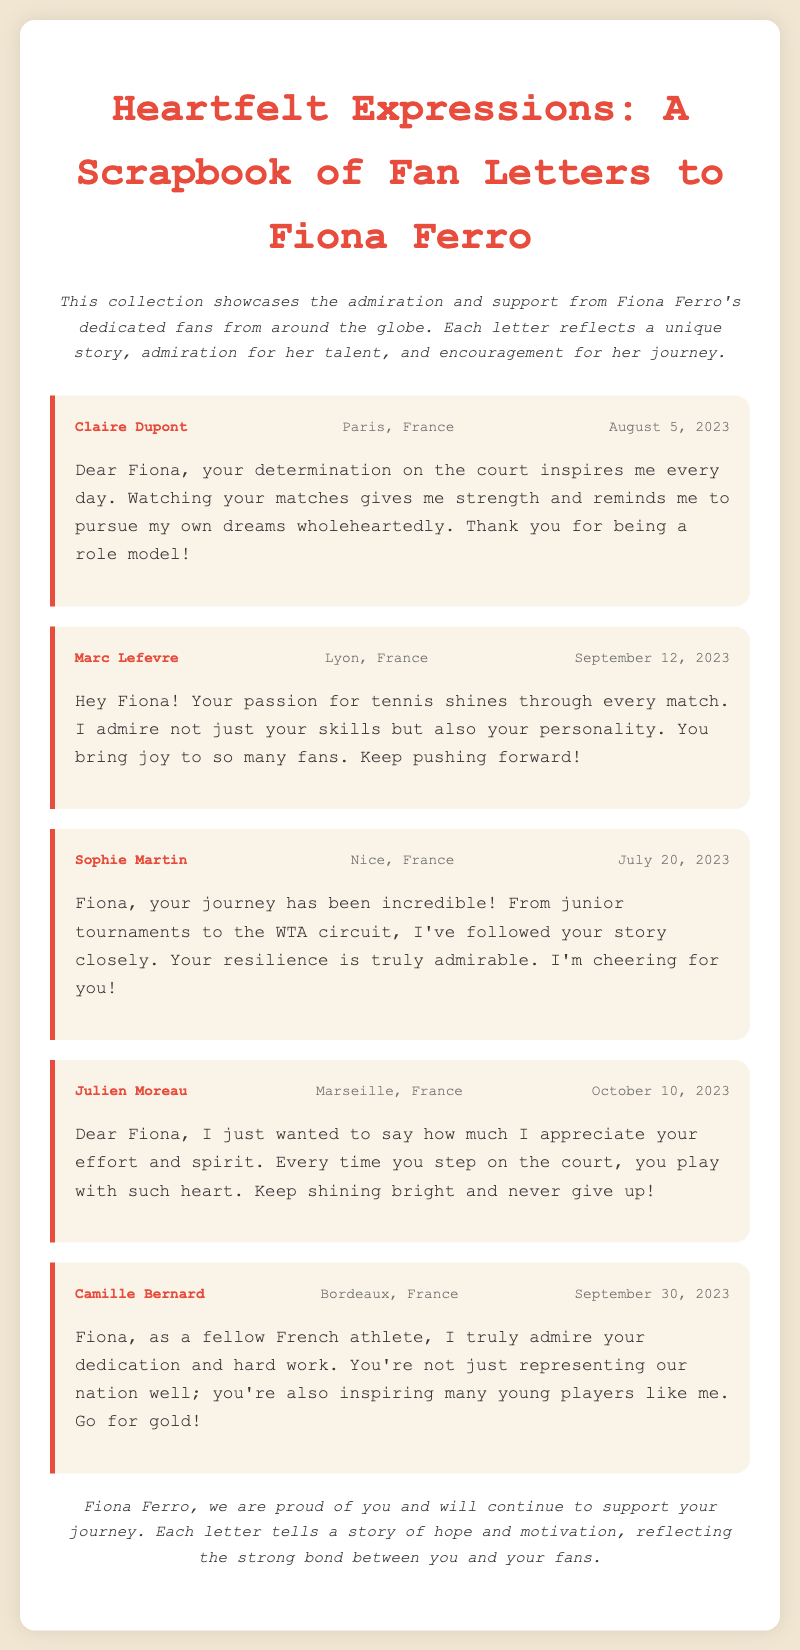What is the title of the scrapbook? The title of the scrapbook is stated at the top of the document, highlighting its content about fan letters.
Answer: Heartfelt Expressions: A Scrapbook of Fan Letters to Fiona Ferro Who wrote the letter dated July 20, 2023? The letter from July 20, 2023, is authored by Sophie Martin, whose name is specified in the letter header.
Answer: Sophie Martin What city is Claire Dupont from? The letter header indicates the location of the author, Claire Dupont, as Paris, France.
Answer: Paris, France How many letters are included in the scrapbook? The document contains a total of five letters addressed to Fiona Ferro, each from different fans.
Answer: Five What does Julien Moreau appreciate about Fiona's performance? Julien Moreau mentions appreciation for Fiona's effort and spirit in his letter.
Answer: Effort and spirit Which fan expresses admiration as a fellow athlete? Camille Bernard identifies as a fellow French athlete in her letter, showcasing a personal connection.
Answer: Camille Bernard What emotion do the letters primarily express towards Fiona Ferro? The letters convey admiration and support, as highlighted in their content and overall tone.
Answer: Admiration and support When was the last letter written? The last letter dated October 10, 2023, is the most recent one in the scrapbook timeline.
Answer: October 10, 2023 What common theme is found in all the letters? The letters share a common theme of encouragement and inspiration regarding Fiona's tennis career.
Answer: Encouragement and inspiration 